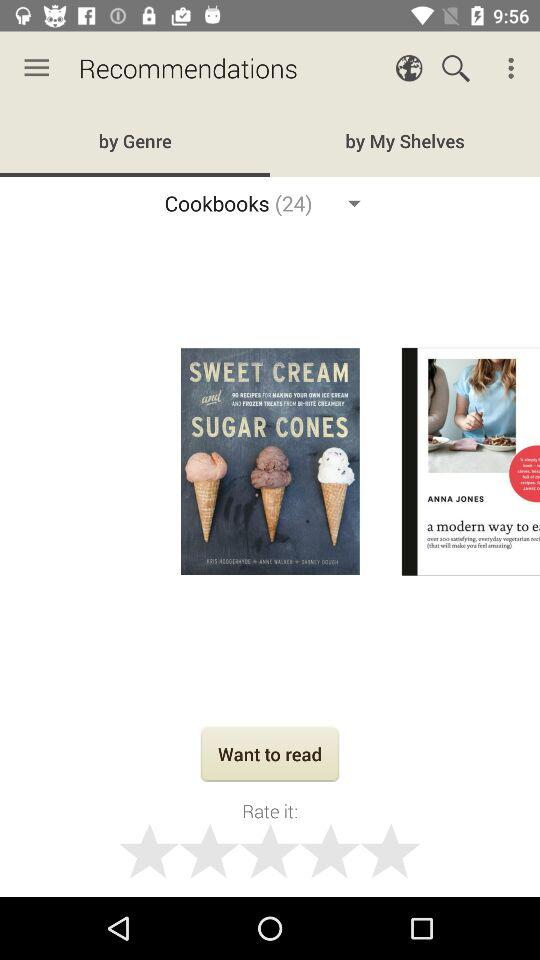How many cookbooks are available? There are 24 cookbooks. 